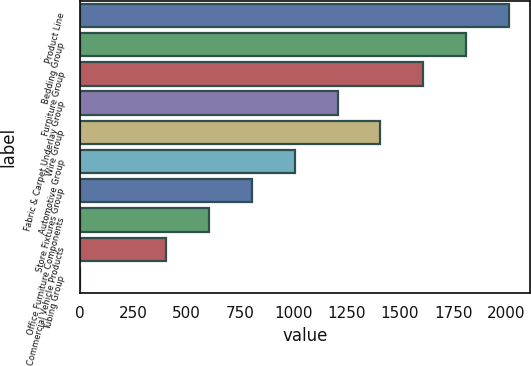Convert chart to OTSL. <chart><loc_0><loc_0><loc_500><loc_500><bar_chart><fcel>Product Line<fcel>Bedding Group<fcel>Furniture Group<fcel>Fabric & Carpet Underlay Group<fcel>Wire Group<fcel>Automotive Group<fcel>Store Fixtures Group<fcel>Office Furniture Components<fcel>Commercial Vehicle Products<fcel>Tubing Group<nl><fcel>2011<fcel>1810.1<fcel>1609.2<fcel>1207.4<fcel>1408.3<fcel>1006.5<fcel>805.6<fcel>604.7<fcel>403.8<fcel>2<nl></chart> 